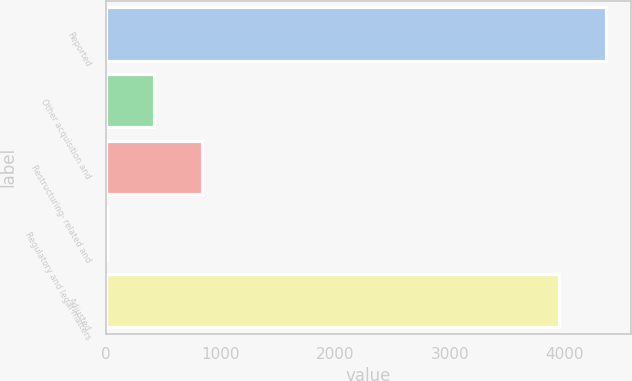Convert chart. <chart><loc_0><loc_0><loc_500><loc_500><bar_chart><fcel>Reported<fcel>Other acquisition and<fcel>Restructuring- related and<fcel>Regulatory and legal matters<fcel>Adjusted<nl><fcel>4356.5<fcel>424.5<fcel>837<fcel>12<fcel>3944<nl></chart> 